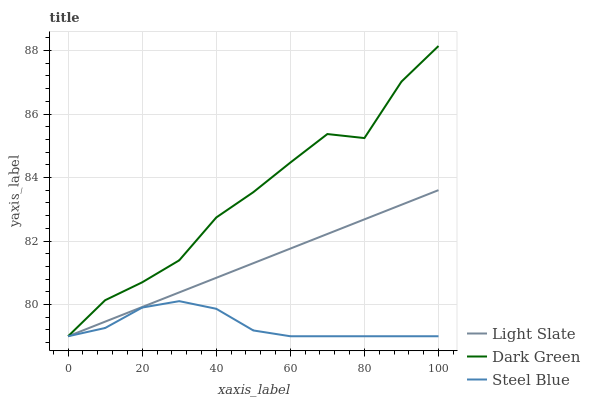Does Steel Blue have the minimum area under the curve?
Answer yes or no. Yes. Does Dark Green have the maximum area under the curve?
Answer yes or no. Yes. Does Dark Green have the minimum area under the curve?
Answer yes or no. No. Does Steel Blue have the maximum area under the curve?
Answer yes or no. No. Is Light Slate the smoothest?
Answer yes or no. Yes. Is Dark Green the roughest?
Answer yes or no. Yes. Is Steel Blue the smoothest?
Answer yes or no. No. Is Steel Blue the roughest?
Answer yes or no. No. Does Dark Green have the highest value?
Answer yes or no. Yes. Does Steel Blue have the highest value?
Answer yes or no. No. Does Light Slate intersect Dark Green?
Answer yes or no. Yes. Is Light Slate less than Dark Green?
Answer yes or no. No. Is Light Slate greater than Dark Green?
Answer yes or no. No. 